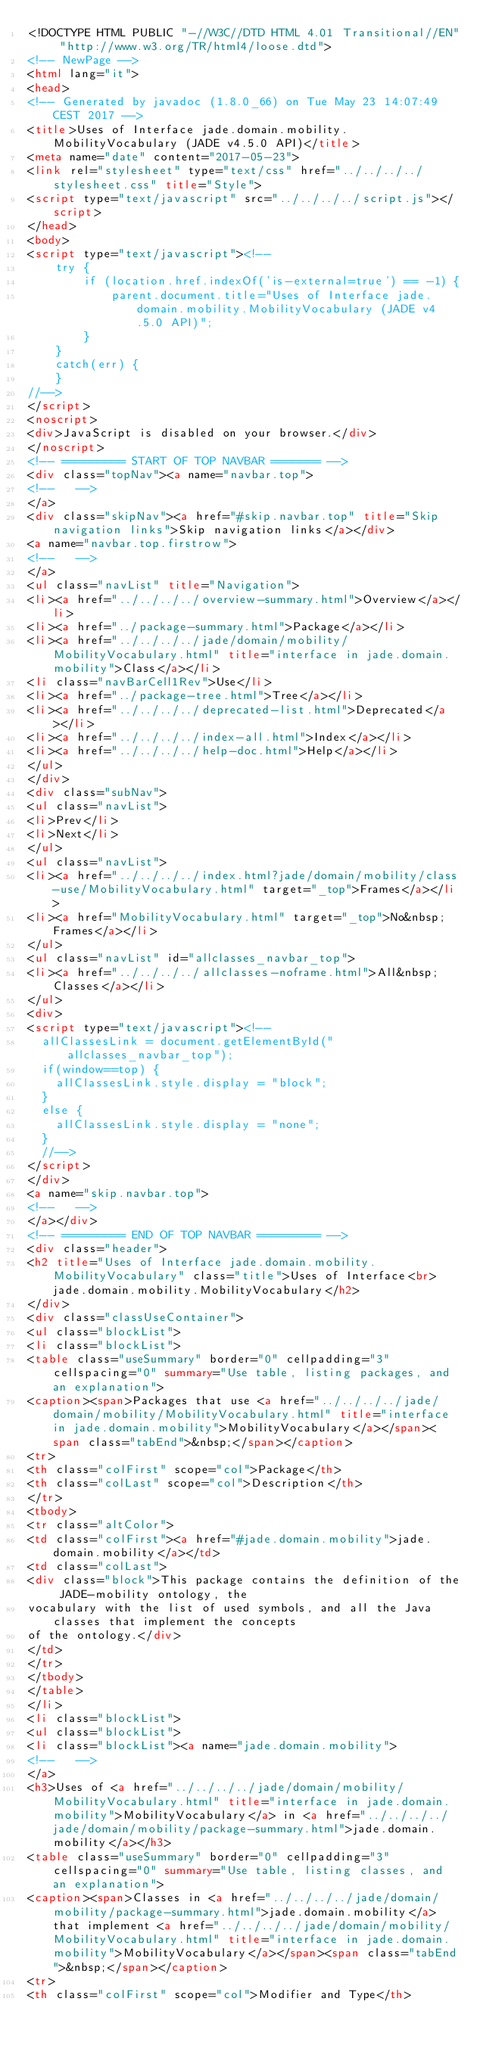Convert code to text. <code><loc_0><loc_0><loc_500><loc_500><_HTML_><!DOCTYPE HTML PUBLIC "-//W3C//DTD HTML 4.01 Transitional//EN" "http://www.w3.org/TR/html4/loose.dtd">
<!-- NewPage -->
<html lang="it">
<head>
<!-- Generated by javadoc (1.8.0_66) on Tue May 23 14:07:49 CEST 2017 -->
<title>Uses of Interface jade.domain.mobility.MobilityVocabulary (JADE v4.5.0 API)</title>
<meta name="date" content="2017-05-23">
<link rel="stylesheet" type="text/css" href="../../../../stylesheet.css" title="Style">
<script type="text/javascript" src="../../../../script.js"></script>
</head>
<body>
<script type="text/javascript"><!--
    try {
        if (location.href.indexOf('is-external=true') == -1) {
            parent.document.title="Uses of Interface jade.domain.mobility.MobilityVocabulary (JADE v4.5.0 API)";
        }
    }
    catch(err) {
    }
//-->
</script>
<noscript>
<div>JavaScript is disabled on your browser.</div>
</noscript>
<!-- ========= START OF TOP NAVBAR ======= -->
<div class="topNav"><a name="navbar.top">
<!--   -->
</a>
<div class="skipNav"><a href="#skip.navbar.top" title="Skip navigation links">Skip navigation links</a></div>
<a name="navbar.top.firstrow">
<!--   -->
</a>
<ul class="navList" title="Navigation">
<li><a href="../../../../overview-summary.html">Overview</a></li>
<li><a href="../package-summary.html">Package</a></li>
<li><a href="../../../../jade/domain/mobility/MobilityVocabulary.html" title="interface in jade.domain.mobility">Class</a></li>
<li class="navBarCell1Rev">Use</li>
<li><a href="../package-tree.html">Tree</a></li>
<li><a href="../../../../deprecated-list.html">Deprecated</a></li>
<li><a href="../../../../index-all.html">Index</a></li>
<li><a href="../../../../help-doc.html">Help</a></li>
</ul>
</div>
<div class="subNav">
<ul class="navList">
<li>Prev</li>
<li>Next</li>
</ul>
<ul class="navList">
<li><a href="../../../../index.html?jade/domain/mobility/class-use/MobilityVocabulary.html" target="_top">Frames</a></li>
<li><a href="MobilityVocabulary.html" target="_top">No&nbsp;Frames</a></li>
</ul>
<ul class="navList" id="allclasses_navbar_top">
<li><a href="../../../../allclasses-noframe.html">All&nbsp;Classes</a></li>
</ul>
<div>
<script type="text/javascript"><!--
  allClassesLink = document.getElementById("allclasses_navbar_top");
  if(window==top) {
    allClassesLink.style.display = "block";
  }
  else {
    allClassesLink.style.display = "none";
  }
  //-->
</script>
</div>
<a name="skip.navbar.top">
<!--   -->
</a></div>
<!-- ========= END OF TOP NAVBAR ========= -->
<div class="header">
<h2 title="Uses of Interface jade.domain.mobility.MobilityVocabulary" class="title">Uses of Interface<br>jade.domain.mobility.MobilityVocabulary</h2>
</div>
<div class="classUseContainer">
<ul class="blockList">
<li class="blockList">
<table class="useSummary" border="0" cellpadding="3" cellspacing="0" summary="Use table, listing packages, and an explanation">
<caption><span>Packages that use <a href="../../../../jade/domain/mobility/MobilityVocabulary.html" title="interface in jade.domain.mobility">MobilityVocabulary</a></span><span class="tabEnd">&nbsp;</span></caption>
<tr>
<th class="colFirst" scope="col">Package</th>
<th class="colLast" scope="col">Description</th>
</tr>
<tbody>
<tr class="altColor">
<td class="colFirst"><a href="#jade.domain.mobility">jade.domain.mobility</a></td>
<td class="colLast">
<div class="block">This package contains the definition of the JADE-mobility ontology, the
vocabulary with the list of used symbols, and all the Java classes that implement the concepts
of the ontology.</div>
</td>
</tr>
</tbody>
</table>
</li>
<li class="blockList">
<ul class="blockList">
<li class="blockList"><a name="jade.domain.mobility">
<!--   -->
</a>
<h3>Uses of <a href="../../../../jade/domain/mobility/MobilityVocabulary.html" title="interface in jade.domain.mobility">MobilityVocabulary</a> in <a href="../../../../jade/domain/mobility/package-summary.html">jade.domain.mobility</a></h3>
<table class="useSummary" border="0" cellpadding="3" cellspacing="0" summary="Use table, listing classes, and an explanation">
<caption><span>Classes in <a href="../../../../jade/domain/mobility/package-summary.html">jade.domain.mobility</a> that implement <a href="../../../../jade/domain/mobility/MobilityVocabulary.html" title="interface in jade.domain.mobility">MobilityVocabulary</a></span><span class="tabEnd">&nbsp;</span></caption>
<tr>
<th class="colFirst" scope="col">Modifier and Type</th></code> 